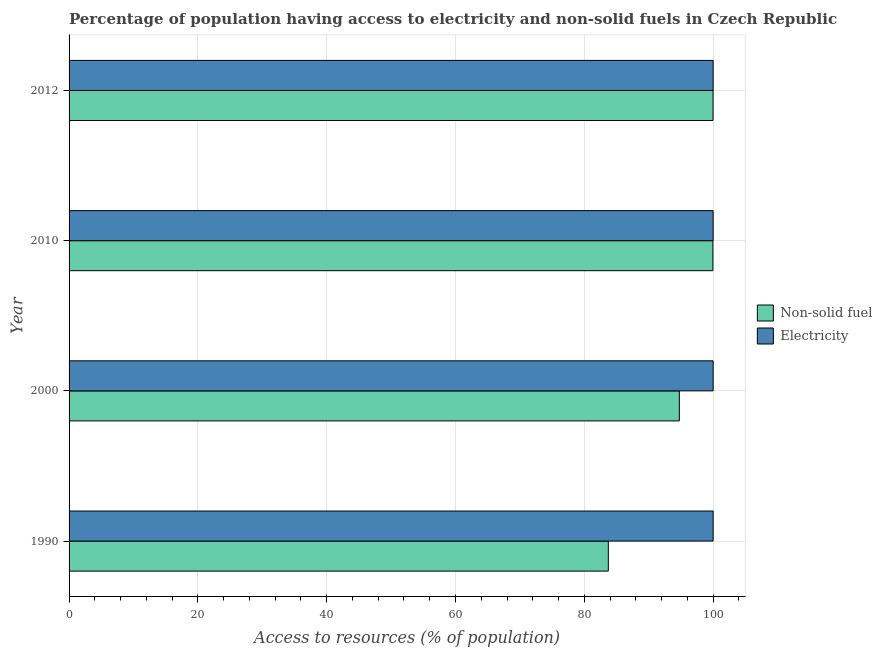How many groups of bars are there?
Your answer should be very brief. 4. Are the number of bars per tick equal to the number of legend labels?
Your answer should be very brief. Yes. Are the number of bars on each tick of the Y-axis equal?
Provide a succinct answer. Yes. How many bars are there on the 2nd tick from the bottom?
Your response must be concise. 2. What is the percentage of population having access to electricity in 2010?
Provide a succinct answer. 100. Across all years, what is the maximum percentage of population having access to non-solid fuel?
Offer a very short reply. 99.99. Across all years, what is the minimum percentage of population having access to non-solid fuel?
Your answer should be very brief. 83.73. What is the total percentage of population having access to electricity in the graph?
Your answer should be compact. 400. What is the difference between the percentage of population having access to non-solid fuel in 2000 and that in 2012?
Ensure brevity in your answer.  -5.24. What is the difference between the percentage of population having access to electricity in 2000 and the percentage of population having access to non-solid fuel in 2010?
Ensure brevity in your answer.  0.04. What is the average percentage of population having access to non-solid fuel per year?
Provide a succinct answer. 94.61. In the year 2012, what is the difference between the percentage of population having access to non-solid fuel and percentage of population having access to electricity?
Your response must be concise. -0.01. What is the ratio of the percentage of population having access to electricity in 1990 to that in 2012?
Ensure brevity in your answer.  1. Is the difference between the percentage of population having access to electricity in 2000 and 2010 greater than the difference between the percentage of population having access to non-solid fuel in 2000 and 2010?
Your answer should be very brief. Yes. What is the difference between the highest and the second highest percentage of population having access to non-solid fuel?
Offer a terse response. 0.03. What is the difference between the highest and the lowest percentage of population having access to non-solid fuel?
Your answer should be compact. 16.26. In how many years, is the percentage of population having access to non-solid fuel greater than the average percentage of population having access to non-solid fuel taken over all years?
Ensure brevity in your answer.  3. What does the 1st bar from the top in 1990 represents?
Give a very brief answer. Electricity. What does the 2nd bar from the bottom in 1990 represents?
Make the answer very short. Electricity. Are all the bars in the graph horizontal?
Provide a short and direct response. Yes. How many years are there in the graph?
Your answer should be compact. 4. Are the values on the major ticks of X-axis written in scientific E-notation?
Your answer should be compact. No. Where does the legend appear in the graph?
Give a very brief answer. Center right. How are the legend labels stacked?
Provide a succinct answer. Vertical. What is the title of the graph?
Offer a terse response. Percentage of population having access to electricity and non-solid fuels in Czech Republic. Does "Mobile cellular" appear as one of the legend labels in the graph?
Your response must be concise. No. What is the label or title of the X-axis?
Offer a terse response. Access to resources (% of population). What is the Access to resources (% of population) of Non-solid fuel in 1990?
Your answer should be compact. 83.73. What is the Access to resources (% of population) in Electricity in 1990?
Provide a succinct answer. 100. What is the Access to resources (% of population) of Non-solid fuel in 2000?
Your answer should be very brief. 94.75. What is the Access to resources (% of population) in Non-solid fuel in 2010?
Offer a terse response. 99.96. What is the Access to resources (% of population) in Non-solid fuel in 2012?
Provide a succinct answer. 99.99. Across all years, what is the maximum Access to resources (% of population) in Non-solid fuel?
Make the answer very short. 99.99. Across all years, what is the minimum Access to resources (% of population) of Non-solid fuel?
Give a very brief answer. 83.73. What is the total Access to resources (% of population) of Non-solid fuel in the graph?
Your answer should be compact. 378.43. What is the difference between the Access to resources (% of population) in Non-solid fuel in 1990 and that in 2000?
Your answer should be compact. -11.02. What is the difference between the Access to resources (% of population) of Non-solid fuel in 1990 and that in 2010?
Ensure brevity in your answer.  -16.24. What is the difference between the Access to resources (% of population) of Non-solid fuel in 1990 and that in 2012?
Provide a short and direct response. -16.26. What is the difference between the Access to resources (% of population) of Non-solid fuel in 2000 and that in 2010?
Offer a terse response. -5.21. What is the difference between the Access to resources (% of population) in Non-solid fuel in 2000 and that in 2012?
Make the answer very short. -5.24. What is the difference between the Access to resources (% of population) of Non-solid fuel in 2010 and that in 2012?
Your answer should be very brief. -0.03. What is the difference between the Access to resources (% of population) in Electricity in 2010 and that in 2012?
Provide a succinct answer. 0. What is the difference between the Access to resources (% of population) in Non-solid fuel in 1990 and the Access to resources (% of population) in Electricity in 2000?
Offer a terse response. -16.27. What is the difference between the Access to resources (% of population) in Non-solid fuel in 1990 and the Access to resources (% of population) in Electricity in 2010?
Your response must be concise. -16.27. What is the difference between the Access to resources (% of population) of Non-solid fuel in 1990 and the Access to resources (% of population) of Electricity in 2012?
Your answer should be compact. -16.27. What is the difference between the Access to resources (% of population) in Non-solid fuel in 2000 and the Access to resources (% of population) in Electricity in 2010?
Offer a terse response. -5.25. What is the difference between the Access to resources (% of population) in Non-solid fuel in 2000 and the Access to resources (% of population) in Electricity in 2012?
Keep it short and to the point. -5.25. What is the difference between the Access to resources (% of population) of Non-solid fuel in 2010 and the Access to resources (% of population) of Electricity in 2012?
Your answer should be very brief. -0.04. What is the average Access to resources (% of population) of Non-solid fuel per year?
Offer a very short reply. 94.61. What is the average Access to resources (% of population) in Electricity per year?
Your answer should be compact. 100. In the year 1990, what is the difference between the Access to resources (% of population) in Non-solid fuel and Access to resources (% of population) in Electricity?
Give a very brief answer. -16.27. In the year 2000, what is the difference between the Access to resources (% of population) of Non-solid fuel and Access to resources (% of population) of Electricity?
Provide a succinct answer. -5.25. In the year 2010, what is the difference between the Access to resources (% of population) in Non-solid fuel and Access to resources (% of population) in Electricity?
Offer a terse response. -0.04. In the year 2012, what is the difference between the Access to resources (% of population) of Non-solid fuel and Access to resources (% of population) of Electricity?
Offer a very short reply. -0.01. What is the ratio of the Access to resources (% of population) in Non-solid fuel in 1990 to that in 2000?
Your response must be concise. 0.88. What is the ratio of the Access to resources (% of population) of Non-solid fuel in 1990 to that in 2010?
Your response must be concise. 0.84. What is the ratio of the Access to resources (% of population) in Electricity in 1990 to that in 2010?
Provide a succinct answer. 1. What is the ratio of the Access to resources (% of population) in Non-solid fuel in 1990 to that in 2012?
Your answer should be compact. 0.84. What is the ratio of the Access to resources (% of population) in Non-solid fuel in 2000 to that in 2010?
Your answer should be very brief. 0.95. What is the ratio of the Access to resources (% of population) of Electricity in 2000 to that in 2010?
Give a very brief answer. 1. What is the ratio of the Access to resources (% of population) in Non-solid fuel in 2000 to that in 2012?
Make the answer very short. 0.95. What is the ratio of the Access to resources (% of population) in Electricity in 2000 to that in 2012?
Keep it short and to the point. 1. What is the ratio of the Access to resources (% of population) in Non-solid fuel in 2010 to that in 2012?
Ensure brevity in your answer.  1. What is the difference between the highest and the second highest Access to resources (% of population) of Non-solid fuel?
Provide a succinct answer. 0.03. What is the difference between the highest and the lowest Access to resources (% of population) of Non-solid fuel?
Offer a very short reply. 16.26. 